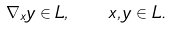Convert formula to latex. <formula><loc_0><loc_0><loc_500><loc_500>\nabla _ { x } y \in L , \quad x , y \in L .</formula> 